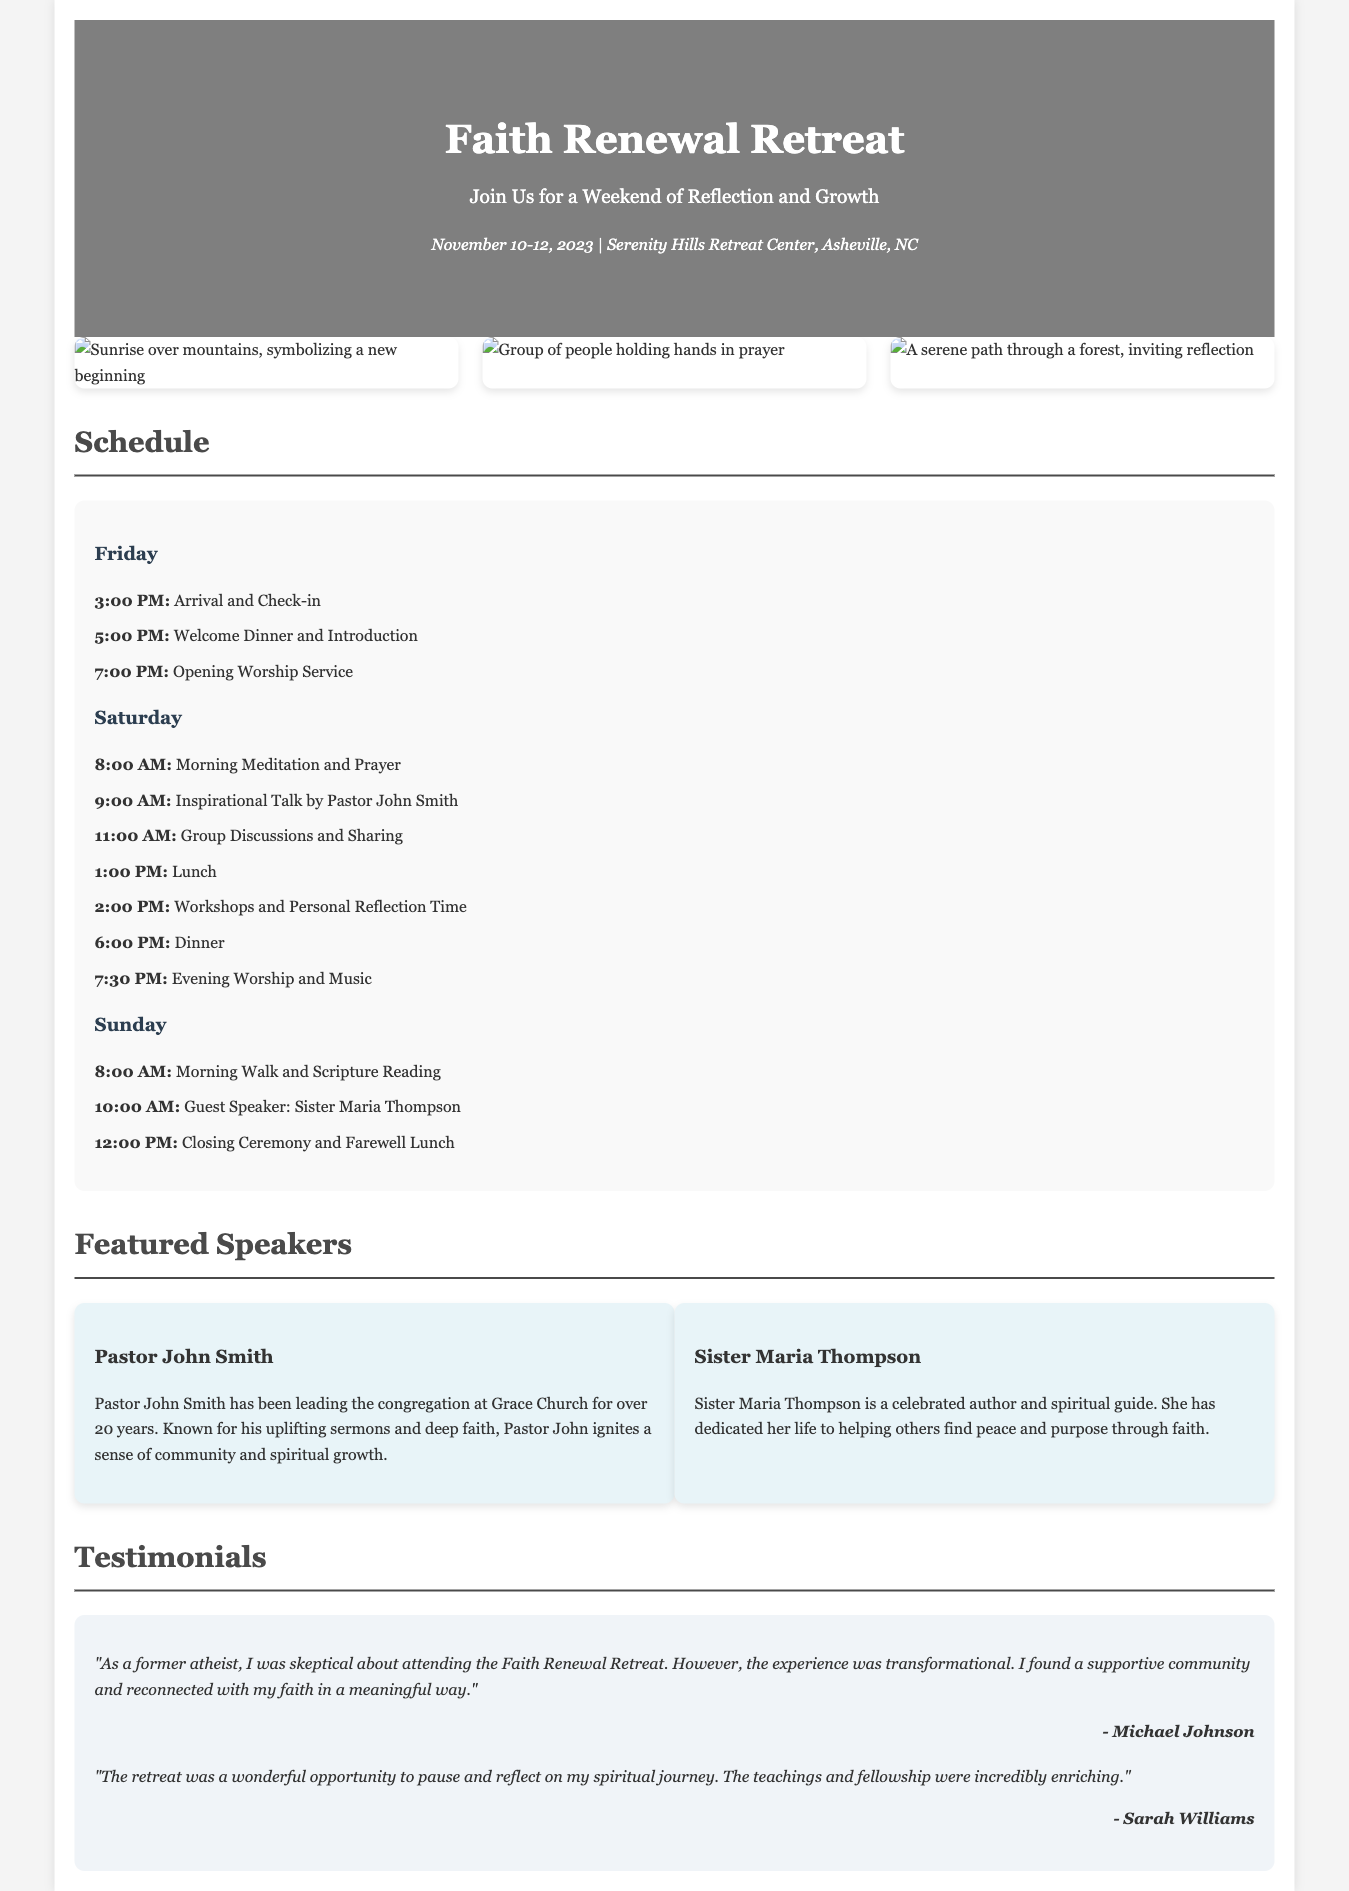What are the dates of the retreat? The dates are clearly stated in the document under the date-location section.
Answer: November 10-12, 2023 Where is the retreat located? The location is mentioned in the same section as the dates.
Answer: Serenity Hills Retreat Center, Asheville, NC Who is the guest speaker on Sunday? The document includes a list of featured speakers with their speaking times, including a guest speaker on Sunday.
Answer: Sister Maria Thompson What time does the welcome dinner start? The schedule provides a specific time for the welcome dinner on Friday evening.
Answer: 5:00 PM What kind of activities are included in the retreat? The schedule lists various activities throughout the weekend, providing insight into the type of experiences offered.
Answer: Meditation, Worship, Workshops How long has Pastor John Smith been leading his congregation? The biography section for Pastor John Smith contains information about his years of service.
Answer: Over 20 years What was Michael Johnson's initial attitude towards the retreat? The testimonials section includes a statement from Michael Johnson describing his initial feelings about the retreat.
Answer: Skeptical What is the theme of the advertisement? The main heading and subtitle suggest a focus on personal development and spirituality.
Answer: Reflection and Growth 